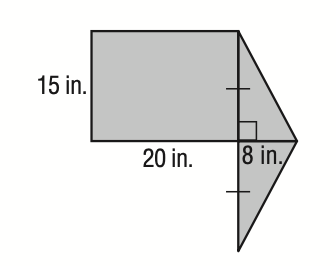Answer the mathemtical geometry problem and directly provide the correct option letter.
Question: Find the area of the shaded figure in square inches. Round to the nearest tenth.
Choices: A: 210 B: 300 C: 420 D: 840 C 